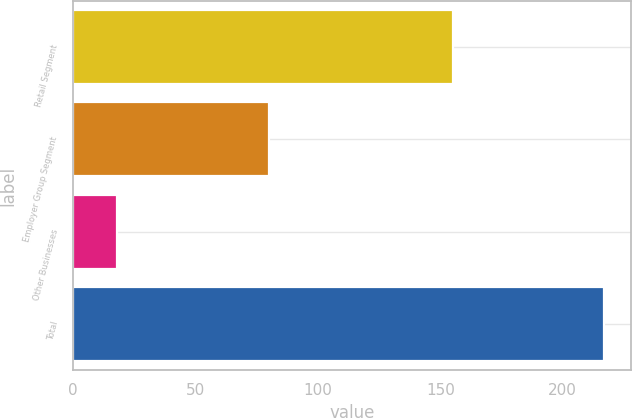Convert chart to OTSL. <chart><loc_0><loc_0><loc_500><loc_500><bar_chart><fcel>Retail Segment<fcel>Employer Group Segment<fcel>Other Businesses<fcel>Total<nl><fcel>155<fcel>80<fcel>18<fcel>217<nl></chart> 